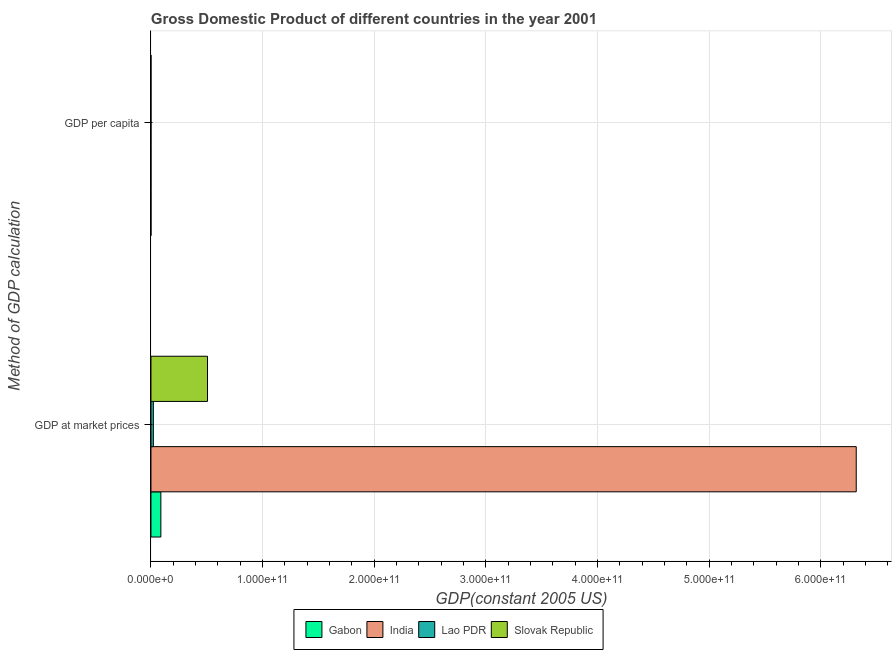How many groups of bars are there?
Your answer should be very brief. 2. How many bars are there on the 2nd tick from the top?
Provide a short and direct response. 4. What is the label of the 1st group of bars from the top?
Provide a succinct answer. GDP per capita. What is the gdp per capita in Lao PDR?
Your answer should be very brief. 394.03. Across all countries, what is the maximum gdp at market prices?
Make the answer very short. 6.32e+11. Across all countries, what is the minimum gdp per capita?
Offer a very short reply. 394.03. In which country was the gdp per capita minimum?
Give a very brief answer. Lao PDR. What is the total gdp per capita in the graph?
Give a very brief answer. 1.74e+04. What is the difference between the gdp at market prices in Lao PDR and that in Gabon?
Offer a terse response. -6.73e+09. What is the difference between the gdp per capita in Lao PDR and the gdp at market prices in Slovak Republic?
Keep it short and to the point. -5.06e+1. What is the average gdp at market prices per country?
Provide a short and direct response. 1.73e+11. What is the difference between the gdp per capita and gdp at market prices in Slovak Republic?
Your answer should be compact. -5.06e+1. What is the ratio of the gdp at market prices in Gabon to that in Lao PDR?
Your answer should be compact. 4.15. Is the gdp at market prices in Lao PDR less than that in India?
Offer a very short reply. Yes. What does the 2nd bar from the top in GDP per capita represents?
Your response must be concise. Lao PDR. What does the 4th bar from the bottom in GDP at market prices represents?
Ensure brevity in your answer.  Slovak Republic. Are all the bars in the graph horizontal?
Give a very brief answer. Yes. What is the difference between two consecutive major ticks on the X-axis?
Your answer should be very brief. 1.00e+11. Where does the legend appear in the graph?
Offer a very short reply. Bottom center. What is the title of the graph?
Your response must be concise. Gross Domestic Product of different countries in the year 2001. What is the label or title of the X-axis?
Keep it short and to the point. GDP(constant 2005 US). What is the label or title of the Y-axis?
Make the answer very short. Method of GDP calculation. What is the GDP(constant 2005 US) in Gabon in GDP at market prices?
Offer a terse response. 8.86e+09. What is the GDP(constant 2005 US) in India in GDP at market prices?
Make the answer very short. 6.32e+11. What is the GDP(constant 2005 US) of Lao PDR in GDP at market prices?
Offer a terse response. 2.14e+09. What is the GDP(constant 2005 US) in Slovak Republic in GDP at market prices?
Make the answer very short. 5.06e+1. What is the GDP(constant 2005 US) in Gabon in GDP per capita?
Ensure brevity in your answer.  7033.11. What is the GDP(constant 2005 US) of India in GDP per capita?
Provide a short and direct response. 589.36. What is the GDP(constant 2005 US) of Lao PDR in GDP per capita?
Offer a very short reply. 394.03. What is the GDP(constant 2005 US) in Slovak Republic in GDP per capita?
Offer a very short reply. 9415.06. Across all Method of GDP calculation, what is the maximum GDP(constant 2005 US) in Gabon?
Provide a succinct answer. 8.86e+09. Across all Method of GDP calculation, what is the maximum GDP(constant 2005 US) in India?
Your answer should be compact. 6.32e+11. Across all Method of GDP calculation, what is the maximum GDP(constant 2005 US) of Lao PDR?
Your answer should be compact. 2.14e+09. Across all Method of GDP calculation, what is the maximum GDP(constant 2005 US) of Slovak Republic?
Your answer should be very brief. 5.06e+1. Across all Method of GDP calculation, what is the minimum GDP(constant 2005 US) of Gabon?
Keep it short and to the point. 7033.11. Across all Method of GDP calculation, what is the minimum GDP(constant 2005 US) of India?
Offer a very short reply. 589.36. Across all Method of GDP calculation, what is the minimum GDP(constant 2005 US) of Lao PDR?
Make the answer very short. 394.03. Across all Method of GDP calculation, what is the minimum GDP(constant 2005 US) of Slovak Republic?
Keep it short and to the point. 9415.06. What is the total GDP(constant 2005 US) in Gabon in the graph?
Your response must be concise. 8.86e+09. What is the total GDP(constant 2005 US) in India in the graph?
Provide a succinct answer. 6.32e+11. What is the total GDP(constant 2005 US) of Lao PDR in the graph?
Offer a very short reply. 2.14e+09. What is the total GDP(constant 2005 US) of Slovak Republic in the graph?
Your answer should be compact. 5.06e+1. What is the difference between the GDP(constant 2005 US) of Gabon in GDP at market prices and that in GDP per capita?
Offer a very short reply. 8.86e+09. What is the difference between the GDP(constant 2005 US) of India in GDP at market prices and that in GDP per capita?
Provide a succinct answer. 6.32e+11. What is the difference between the GDP(constant 2005 US) of Lao PDR in GDP at market prices and that in GDP per capita?
Provide a succinct answer. 2.14e+09. What is the difference between the GDP(constant 2005 US) in Slovak Republic in GDP at market prices and that in GDP per capita?
Provide a short and direct response. 5.06e+1. What is the difference between the GDP(constant 2005 US) of Gabon in GDP at market prices and the GDP(constant 2005 US) of India in GDP per capita?
Offer a very short reply. 8.86e+09. What is the difference between the GDP(constant 2005 US) in Gabon in GDP at market prices and the GDP(constant 2005 US) in Lao PDR in GDP per capita?
Give a very brief answer. 8.86e+09. What is the difference between the GDP(constant 2005 US) in Gabon in GDP at market prices and the GDP(constant 2005 US) in Slovak Republic in GDP per capita?
Make the answer very short. 8.86e+09. What is the difference between the GDP(constant 2005 US) of India in GDP at market prices and the GDP(constant 2005 US) of Lao PDR in GDP per capita?
Your response must be concise. 6.32e+11. What is the difference between the GDP(constant 2005 US) in India in GDP at market prices and the GDP(constant 2005 US) in Slovak Republic in GDP per capita?
Give a very brief answer. 6.32e+11. What is the difference between the GDP(constant 2005 US) in Lao PDR in GDP at market prices and the GDP(constant 2005 US) in Slovak Republic in GDP per capita?
Offer a terse response. 2.14e+09. What is the average GDP(constant 2005 US) in Gabon per Method of GDP calculation?
Make the answer very short. 4.43e+09. What is the average GDP(constant 2005 US) in India per Method of GDP calculation?
Provide a short and direct response. 3.16e+11. What is the average GDP(constant 2005 US) of Lao PDR per Method of GDP calculation?
Your answer should be very brief. 1.07e+09. What is the average GDP(constant 2005 US) of Slovak Republic per Method of GDP calculation?
Make the answer very short. 2.53e+1. What is the difference between the GDP(constant 2005 US) in Gabon and GDP(constant 2005 US) in India in GDP at market prices?
Provide a short and direct response. -6.23e+11. What is the difference between the GDP(constant 2005 US) in Gabon and GDP(constant 2005 US) in Lao PDR in GDP at market prices?
Your response must be concise. 6.73e+09. What is the difference between the GDP(constant 2005 US) in Gabon and GDP(constant 2005 US) in Slovak Republic in GDP at market prices?
Your response must be concise. -4.18e+1. What is the difference between the GDP(constant 2005 US) in India and GDP(constant 2005 US) in Lao PDR in GDP at market prices?
Your answer should be very brief. 6.30e+11. What is the difference between the GDP(constant 2005 US) of India and GDP(constant 2005 US) of Slovak Republic in GDP at market prices?
Your answer should be compact. 5.81e+11. What is the difference between the GDP(constant 2005 US) in Lao PDR and GDP(constant 2005 US) in Slovak Republic in GDP at market prices?
Your answer should be compact. -4.85e+1. What is the difference between the GDP(constant 2005 US) in Gabon and GDP(constant 2005 US) in India in GDP per capita?
Provide a succinct answer. 6443.75. What is the difference between the GDP(constant 2005 US) in Gabon and GDP(constant 2005 US) in Lao PDR in GDP per capita?
Provide a short and direct response. 6639.08. What is the difference between the GDP(constant 2005 US) in Gabon and GDP(constant 2005 US) in Slovak Republic in GDP per capita?
Your response must be concise. -2381.94. What is the difference between the GDP(constant 2005 US) in India and GDP(constant 2005 US) in Lao PDR in GDP per capita?
Provide a succinct answer. 195.33. What is the difference between the GDP(constant 2005 US) of India and GDP(constant 2005 US) of Slovak Republic in GDP per capita?
Provide a short and direct response. -8825.7. What is the difference between the GDP(constant 2005 US) in Lao PDR and GDP(constant 2005 US) in Slovak Republic in GDP per capita?
Your response must be concise. -9021.03. What is the ratio of the GDP(constant 2005 US) of Gabon in GDP at market prices to that in GDP per capita?
Give a very brief answer. 1.26e+06. What is the ratio of the GDP(constant 2005 US) of India in GDP at market prices to that in GDP per capita?
Make the answer very short. 1.07e+09. What is the ratio of the GDP(constant 2005 US) in Lao PDR in GDP at market prices to that in GDP per capita?
Offer a terse response. 5.42e+06. What is the ratio of the GDP(constant 2005 US) of Slovak Republic in GDP at market prices to that in GDP per capita?
Offer a very short reply. 5.38e+06. What is the difference between the highest and the second highest GDP(constant 2005 US) in Gabon?
Ensure brevity in your answer.  8.86e+09. What is the difference between the highest and the second highest GDP(constant 2005 US) in India?
Offer a very short reply. 6.32e+11. What is the difference between the highest and the second highest GDP(constant 2005 US) in Lao PDR?
Provide a succinct answer. 2.14e+09. What is the difference between the highest and the second highest GDP(constant 2005 US) of Slovak Republic?
Offer a very short reply. 5.06e+1. What is the difference between the highest and the lowest GDP(constant 2005 US) of Gabon?
Your answer should be very brief. 8.86e+09. What is the difference between the highest and the lowest GDP(constant 2005 US) in India?
Your answer should be compact. 6.32e+11. What is the difference between the highest and the lowest GDP(constant 2005 US) of Lao PDR?
Your answer should be compact. 2.14e+09. What is the difference between the highest and the lowest GDP(constant 2005 US) in Slovak Republic?
Ensure brevity in your answer.  5.06e+1. 